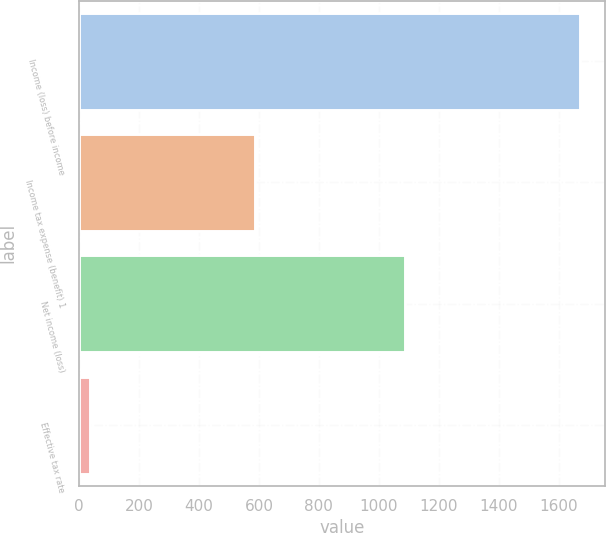Convert chart. <chart><loc_0><loc_0><loc_500><loc_500><bar_chart><fcel>Income (loss) before income<fcel>Income tax expense (benefit) 1<fcel>Net income (loss)<fcel>Effective tax rate<nl><fcel>1671<fcel>586<fcel>1086<fcel>35<nl></chart> 